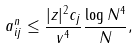Convert formula to latex. <formula><loc_0><loc_0><loc_500><loc_500>a ^ { n } _ { i j } \leq \frac { | z | ^ { 2 } c _ { j } } { v ^ { 4 } } \frac { \log N ^ { 4 } } N ,</formula> 